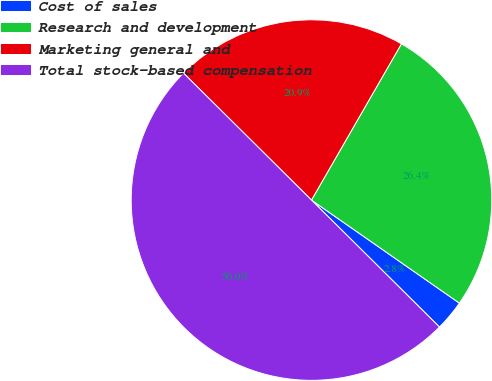Convert chart. <chart><loc_0><loc_0><loc_500><loc_500><pie_chart><fcel>Cost of sales<fcel>Research and development<fcel>Marketing general and<fcel>Total stock-based compensation<nl><fcel>2.75%<fcel>26.37%<fcel>20.88%<fcel>50.0%<nl></chart> 